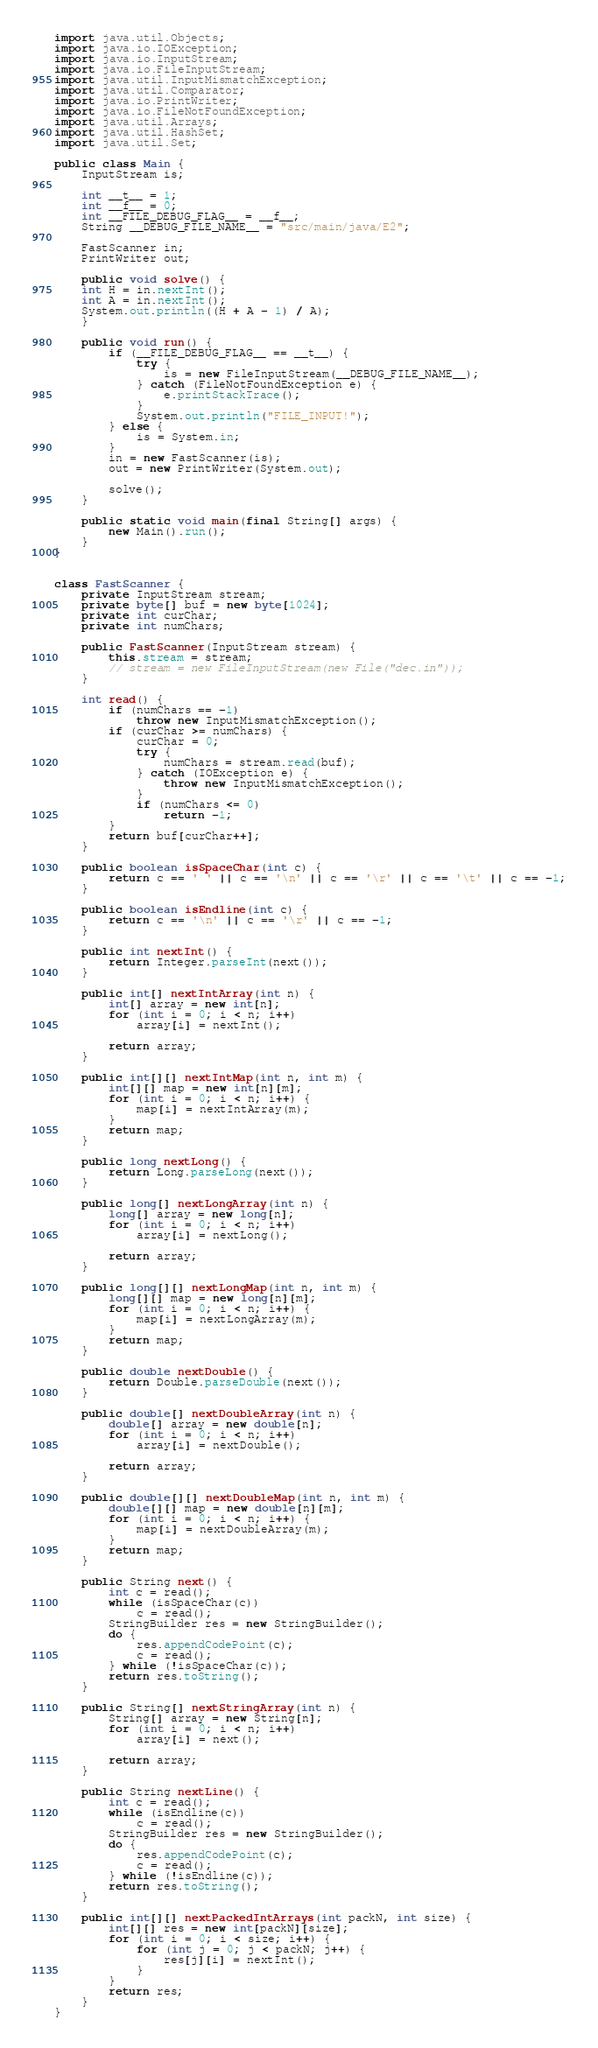Convert code to text. <code><loc_0><loc_0><loc_500><loc_500><_Java_>import java.util.Objects;
import java.io.IOException;
import java.io.InputStream;
import java.io.FileInputStream;
import java.util.InputMismatchException;
import java.util.Comparator;
import java.io.PrintWriter;
import java.io.FileNotFoundException;
import java.util.Arrays;
import java.util.HashSet;
import java.util.Set;

public class Main {
    InputStream is;

    int __t__ = 1;
    int __f__ = 0;
    int __FILE_DEBUG_FLAG__ = __f__;
    String __DEBUG_FILE_NAME__ = "src/main/java/E2";

    FastScanner in;
    PrintWriter out;

    public void solve() {
	int H = in.nextInt();
	int A = in.nextInt();
	System.out.println((H + A - 1) / A);
    }

    public void run() {
        if (__FILE_DEBUG_FLAG__ == __t__) {
            try {
                is = new FileInputStream(__DEBUG_FILE_NAME__);
            } catch (FileNotFoundException e) {
                e.printStackTrace();
            }
            System.out.println("FILE_INPUT!");
        } else {
            is = System.in;
        }
        in = new FastScanner(is);
        out = new PrintWriter(System.out);

        solve();
    }

    public static void main(final String[] args) {
        new Main().run();
    }
}


class FastScanner {
    private InputStream stream;
    private byte[] buf = new byte[1024];
    private int curChar;
    private int numChars;

    public FastScanner(InputStream stream) {
        this.stream = stream;
        // stream = new FileInputStream(new File("dec.in"));
    }

    int read() {
        if (numChars == -1)
            throw new InputMismatchException();
        if (curChar >= numChars) {
            curChar = 0;
            try {
                numChars = stream.read(buf);
            } catch (IOException e) {
                throw new InputMismatchException();
            }
            if (numChars <= 0)
                return -1;
        }
        return buf[curChar++];
    }

    public boolean isSpaceChar(int c) {
        return c == ' ' || c == '\n' || c == '\r' || c == '\t' || c == -1;
    }

    public boolean isEndline(int c) {
        return c == '\n' || c == '\r' || c == -1;
    }

    public int nextInt() {
        return Integer.parseInt(next());
    }

    public int[] nextIntArray(int n) {
        int[] array = new int[n];
        for (int i = 0; i < n; i++)
            array[i] = nextInt();

        return array;
    }

    public int[][] nextIntMap(int n, int m) {
        int[][] map = new int[n][m];
        for (int i = 0; i < n; i++) {
            map[i] = nextIntArray(m);
        }
        return map;
    }

    public long nextLong() {
        return Long.parseLong(next());
    }

    public long[] nextLongArray(int n) {
        long[] array = new long[n];
        for (int i = 0; i < n; i++)
            array[i] = nextLong();

        return array;
    }

    public long[][] nextLongMap(int n, int m) {
        long[][] map = new long[n][m];
        for (int i = 0; i < n; i++) {
            map[i] = nextLongArray(m);
        }
        return map;
    }

    public double nextDouble() {
        return Double.parseDouble(next());
    }

    public double[] nextDoubleArray(int n) {
        double[] array = new double[n];
        for (int i = 0; i < n; i++)
            array[i] = nextDouble();

        return array;
    }

    public double[][] nextDoubleMap(int n, int m) {
        double[][] map = new double[n][m];
        for (int i = 0; i < n; i++) {
            map[i] = nextDoubleArray(m);
        }
        return map;
    }

    public String next() {
        int c = read();
        while (isSpaceChar(c))
            c = read();
        StringBuilder res = new StringBuilder();
        do {
            res.appendCodePoint(c);
            c = read();
        } while (!isSpaceChar(c));
        return res.toString();
    }

    public String[] nextStringArray(int n) {
        String[] array = new String[n];
        for (int i = 0; i < n; i++)
            array[i] = next();

        return array;
    }

    public String nextLine() {
        int c = read();
        while (isEndline(c))
            c = read();
        StringBuilder res = new StringBuilder();
        do {
            res.appendCodePoint(c);
            c = read();
        } while (!isEndline(c));
        return res.toString();
    }

    public int[][] nextPackedIntArrays(int packN, int size) {
        int[][] res = new int[packN][size];
        for (int i = 0; i < size; i++) {
            for (int j = 0; j < packN; j++) {
                res[j][i] = nextInt();
            }
        }
        return res;
    }
}
</code> 